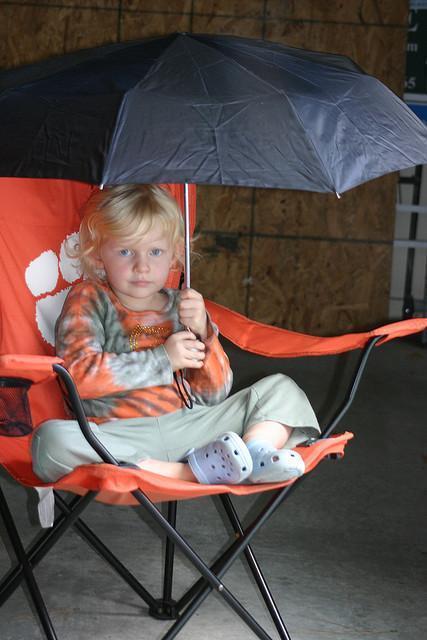How many shoes is the kid wearing?
Give a very brief answer. 2. How many red color pizza on the bowl?
Give a very brief answer. 0. 